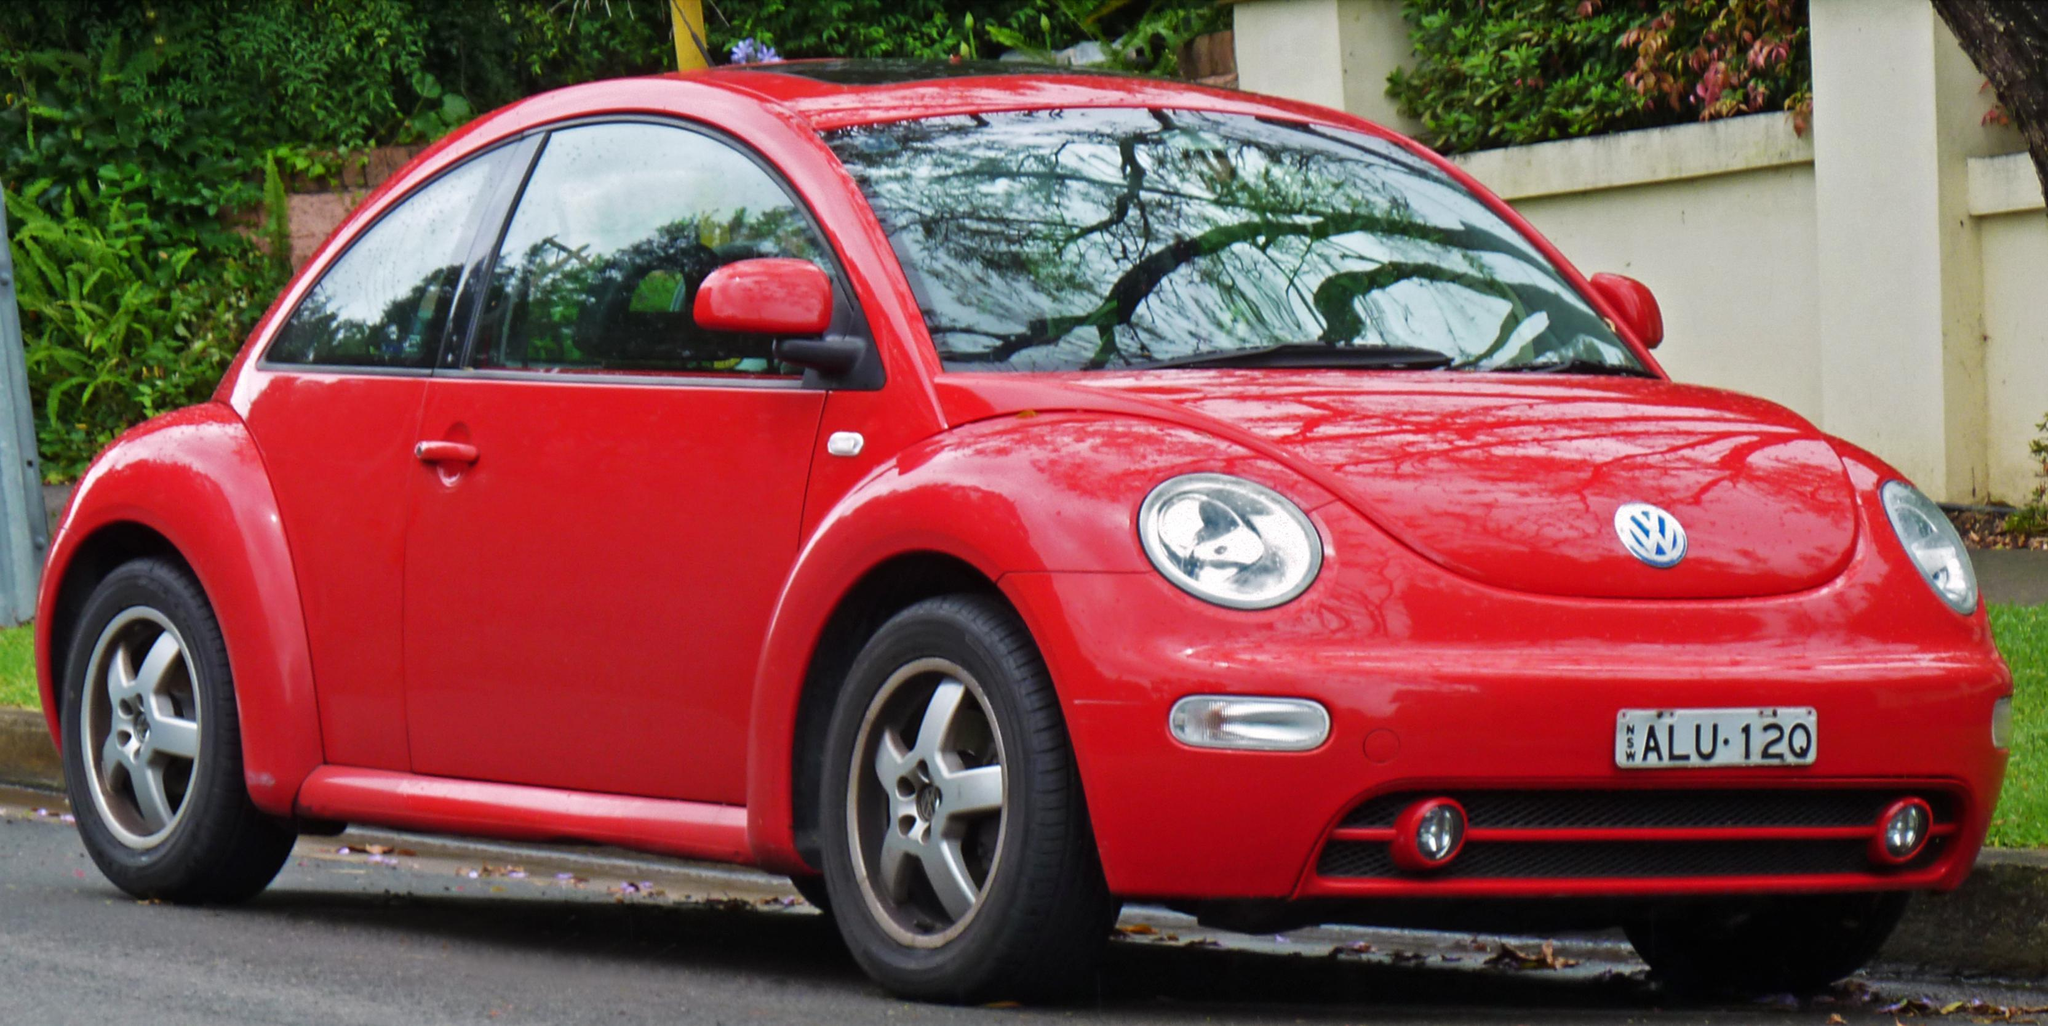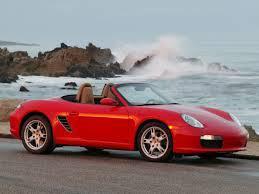The first image is the image on the left, the second image is the image on the right. Given the left and right images, does the statement "In one image, a red convertible is near a body of water, while in a second image, a red car is parked in front of an area of greenery and a white structure." hold true? Answer yes or no. Yes. The first image is the image on the left, the second image is the image on the right. Analyze the images presented: Is the assertion "Right image shows a red forward-angled convertible alongside a rocky shoreline." valid? Answer yes or no. Yes. 